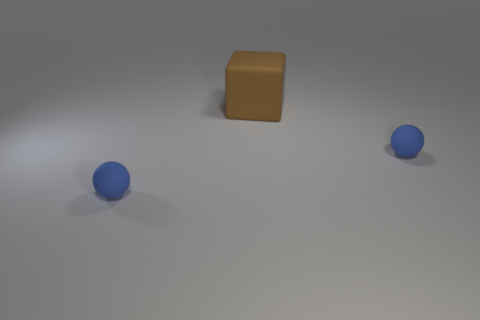Subtract 1 blocks. How many blocks are left? 0 Subtract all balls. How many objects are left? 1 Subtract all purple cylinders. How many brown spheres are left? 0 Subtract all big blocks. Subtract all small green rubber cylinders. How many objects are left? 2 Add 3 large rubber blocks. How many large rubber blocks are left? 4 Add 1 blocks. How many blocks exist? 2 Add 2 blue balls. How many objects exist? 5 Subtract 0 gray cubes. How many objects are left? 3 Subtract all purple cubes. Subtract all yellow spheres. How many cubes are left? 1 